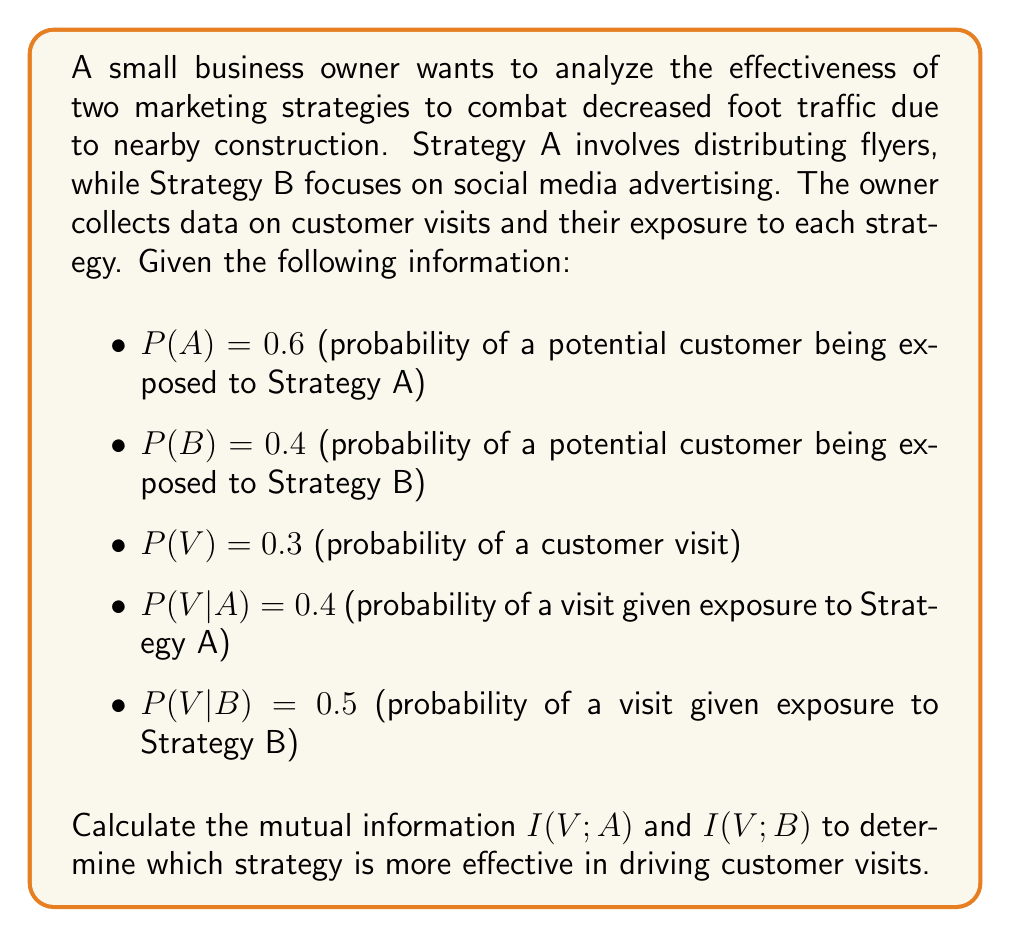Show me your answer to this math problem. To solve this problem, we'll use the concept of mutual information from information theory. Mutual information measures the amount of information obtained about one random variable by observing another random variable. In this case, we want to measure how much information we gain about customer visits (V) by knowing whether they were exposed to Strategy A or B.

The formula for mutual information is:

$$I(X;Y) = \sum_{x \in X} \sum_{y \in Y} p(x,y) \log_2 \left(\frac{p(x,y)}{p(x)p(y)}\right)$$

For binary variables, we can simplify this to:

$$I(X;Y) = p(x,y) \log_2 \left(\frac{p(x,y)}{p(x)p(y)}\right) + p(x,\bar{y}) \log_2 \left(\frac{p(x,\bar{y})}{p(x)p(\bar{y})}\right) + p(\bar{x},y) \log_2 \left(\frac{p(\bar{x},y)}{p(\bar{x})p(y)}\right) + p(\bar{x},\bar{y}) \log_2 \left(\frac{p(\bar{x},\bar{y})}{p(\bar{x})p(\bar{y})}\right)$$

Let's calculate I(V;A) first:

1. Calculate P(V|A) and P(V|not A):
   P(V|A) = 0.4 (given)
   P(V|not A) = (P(V) - P(V|A)P(A)) / (1 - P(A)) = (0.3 - 0.4 * 0.6) / 0.4 = 0.15

2. Calculate joint probabilities:
   P(V,A) = P(V|A) * P(A) = 0.4 * 0.6 = 0.24
   P(not V,A) = P(A) - P(V,A) = 0.6 - 0.24 = 0.36
   P(V,not A) = P(V) - P(V,A) = 0.3 - 0.24 = 0.06
   P(not V,not A) = 1 - P(V,A) - P(not V,A) - P(V,not A) = 1 - 0.24 - 0.36 - 0.06 = 0.34

3. Apply the mutual information formula:
   $$I(V;A) = 0.24 \log_2 \left(\frac{0.24}{0.3 * 0.6}\right) + 0.36 \log_2 \left(\frac{0.36}{0.7 * 0.6}\right) + 0.06 \log_2 \left(\frac{0.06}{0.3 * 0.4}\right) + 0.34 \log_2 \left(\frac{0.34}{0.7 * 0.4}\right)$$
   
   $$I(V;A) \approx 0.0397 \text{ bits}$$

Now let's calculate I(V;B):

1. Calculate P(V|B) and P(V|not B):
   P(V|B) = 0.5 (given)
   P(V|not B) = (P(V) - P(V|B)P(B)) / (1 - P(B)) = (0.3 - 0.5 * 0.4) / 0.6 = 0.1667

2. Calculate joint probabilities:
   P(V,B) = P(V|B) * P(B) = 0.5 * 0.4 = 0.2
   P(not V,B) = P(B) - P(V,B) = 0.4 - 0.2 = 0.2
   P(V,not B) = P(V) - P(V,B) = 0.3 - 0.2 = 0.1
   P(not V,not B) = 1 - P(V,B) - P(not V,B) - P(V,not B) = 1 - 0.2 - 0.2 - 0.1 = 0.5

3. Apply the mutual information formula:
   $$I(V;B) = 0.2 \log_2 \left(\frac{0.2}{0.3 * 0.4}\right) + 0.2 \log_2 \left(\frac{0.2}{0.7 * 0.4}\right) + 0.1 \log_2 \left(\frac{0.1}{0.3 * 0.6}\right) + 0.5 \log_2 \left(\frac{0.5}{0.7 * 0.6}\right)$$
   
   $$I(V;B) \approx 0.0471 \text{ bits}$$
Answer: I(V;A) ≈ 0.0397 bits
I(V;B) ≈ 0.0471 bits

Strategy B (social media advertising) is more effective in driving customer visits, as it has a higher mutual information value with customer visits (0.0471 bits) compared to Strategy A (0.0397 bits). 